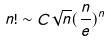<formula> <loc_0><loc_0><loc_500><loc_500>n ! \sim C \sqrt { n } ( \frac { n } { e } ) ^ { n }</formula> 